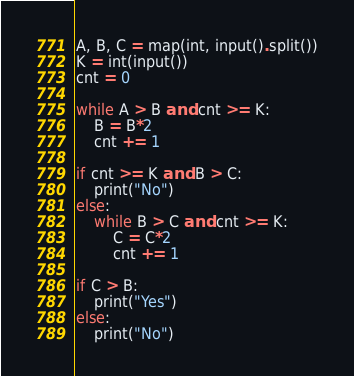<code> <loc_0><loc_0><loc_500><loc_500><_Python_>A, B, C = map(int, input().split())
K = int(input())
cnt = 0

while A > B and cnt >= K:
    B = B*2
    cnt += 1

if cnt >= K and B > C:
    print("No")
else:
    while B > C and cnt >= K:
        C = C*2
        cnt += 1

if C > B:
    print("Yes")
else:
    print("No")
</code> 